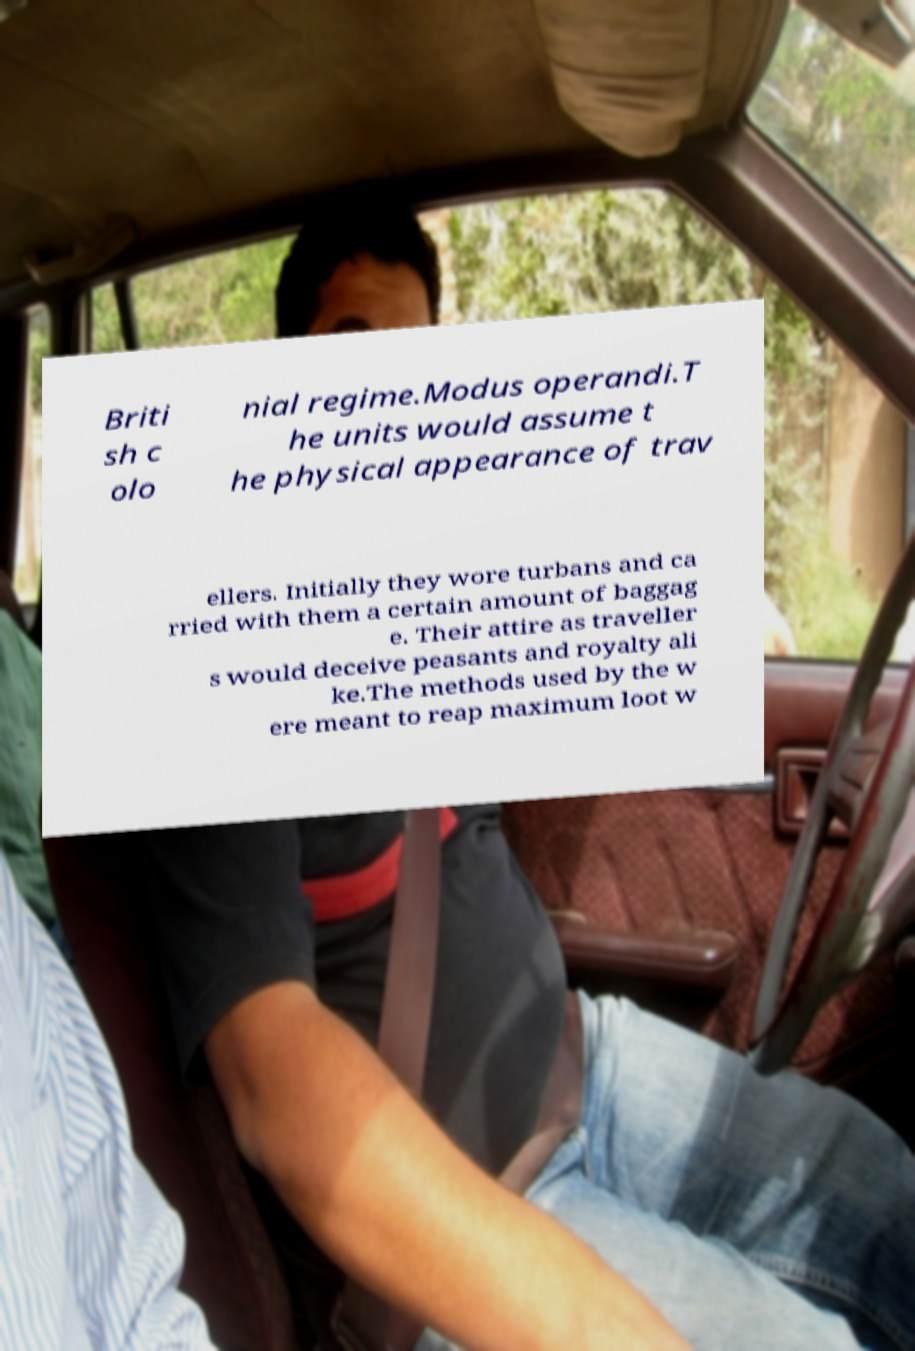Please identify and transcribe the text found in this image. Briti sh c olo nial regime.Modus operandi.T he units would assume t he physical appearance of trav ellers. Initially they wore turbans and ca rried with them a certain amount of baggag e. Their attire as traveller s would deceive peasants and royalty ali ke.The methods used by the w ere meant to reap maximum loot w 